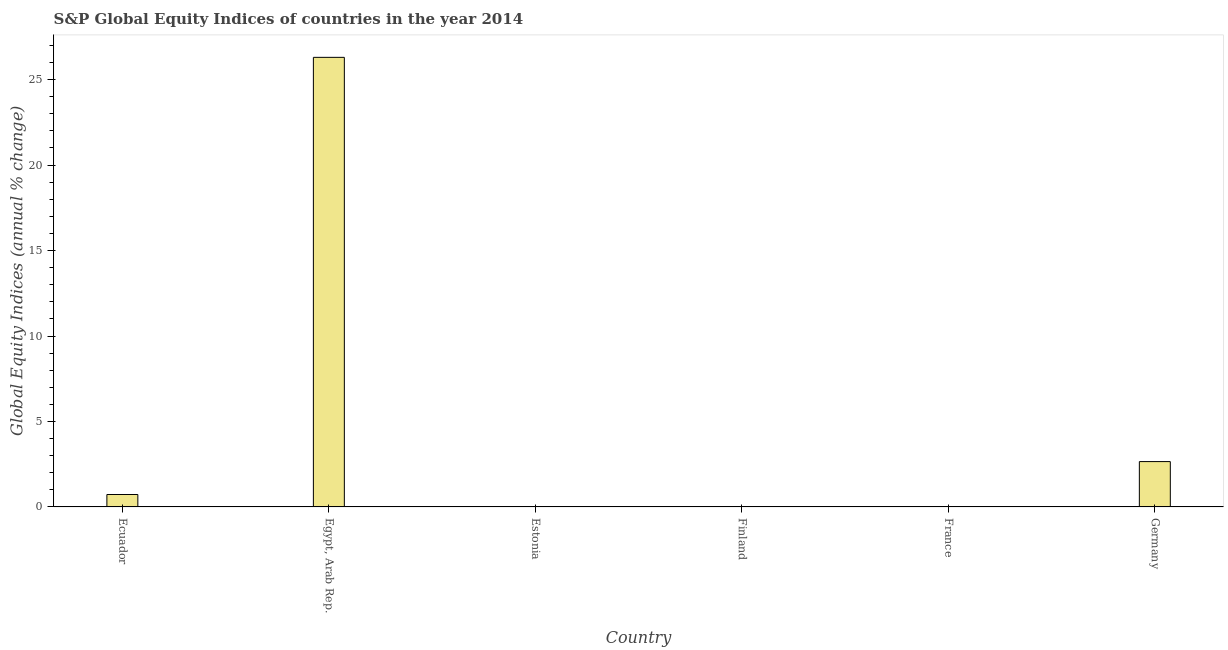Does the graph contain any zero values?
Give a very brief answer. Yes. What is the title of the graph?
Provide a succinct answer. S&P Global Equity Indices of countries in the year 2014. What is the label or title of the Y-axis?
Offer a very short reply. Global Equity Indices (annual % change). Across all countries, what is the maximum s&p global equity indices?
Provide a succinct answer. 26.3. In which country was the s&p global equity indices maximum?
Your answer should be compact. Egypt, Arab Rep. What is the sum of the s&p global equity indices?
Your answer should be very brief. 29.68. What is the difference between the s&p global equity indices in Egypt, Arab Rep. and Germany?
Ensure brevity in your answer.  23.65. What is the average s&p global equity indices per country?
Your answer should be very brief. 4.95. What is the median s&p global equity indices?
Make the answer very short. 0.36. In how many countries, is the s&p global equity indices greater than 4 %?
Provide a succinct answer. 1. What is the ratio of the s&p global equity indices in Egypt, Arab Rep. to that in Germany?
Offer a terse response. 9.91. What is the difference between the highest and the second highest s&p global equity indices?
Your response must be concise. 23.65. Is the sum of the s&p global equity indices in Ecuador and Egypt, Arab Rep. greater than the maximum s&p global equity indices across all countries?
Your answer should be very brief. Yes. What is the difference between the highest and the lowest s&p global equity indices?
Your response must be concise. 26.3. In how many countries, is the s&p global equity indices greater than the average s&p global equity indices taken over all countries?
Ensure brevity in your answer.  1. How many bars are there?
Make the answer very short. 3. How many countries are there in the graph?
Offer a terse response. 6. Are the values on the major ticks of Y-axis written in scientific E-notation?
Offer a terse response. No. What is the Global Equity Indices (annual % change) of Ecuador?
Offer a terse response. 0.73. What is the Global Equity Indices (annual % change) in Egypt, Arab Rep.?
Your answer should be compact. 26.3. What is the Global Equity Indices (annual % change) of Estonia?
Provide a short and direct response. 0. What is the Global Equity Indices (annual % change) in France?
Ensure brevity in your answer.  0. What is the Global Equity Indices (annual % change) in Germany?
Offer a very short reply. 2.65. What is the difference between the Global Equity Indices (annual % change) in Ecuador and Egypt, Arab Rep.?
Your response must be concise. -25.58. What is the difference between the Global Equity Indices (annual % change) in Ecuador and Germany?
Offer a very short reply. -1.93. What is the difference between the Global Equity Indices (annual % change) in Egypt, Arab Rep. and Germany?
Your answer should be very brief. 23.65. What is the ratio of the Global Equity Indices (annual % change) in Ecuador to that in Egypt, Arab Rep.?
Offer a terse response. 0.03. What is the ratio of the Global Equity Indices (annual % change) in Ecuador to that in Germany?
Give a very brief answer. 0.27. What is the ratio of the Global Equity Indices (annual % change) in Egypt, Arab Rep. to that in Germany?
Your response must be concise. 9.91. 